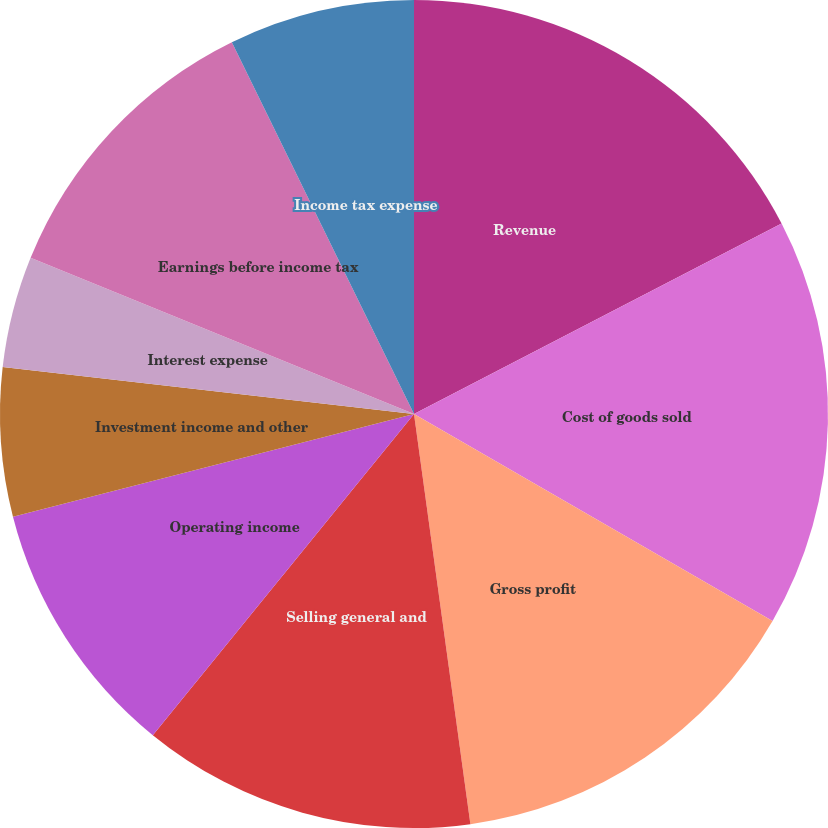Convert chart. <chart><loc_0><loc_0><loc_500><loc_500><pie_chart><fcel>Revenue<fcel>Cost of goods sold<fcel>Gross profit<fcel>Selling general and<fcel>Operating income<fcel>Investment income and other<fcel>Interest expense<fcel>Earnings before income tax<fcel>Income tax expense<fcel>Minority interests in earnings<nl><fcel>17.39%<fcel>15.94%<fcel>14.49%<fcel>13.04%<fcel>10.14%<fcel>5.8%<fcel>4.35%<fcel>11.59%<fcel>7.25%<fcel>0.0%<nl></chart> 